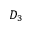<formula> <loc_0><loc_0><loc_500><loc_500>D _ { 3 }</formula> 